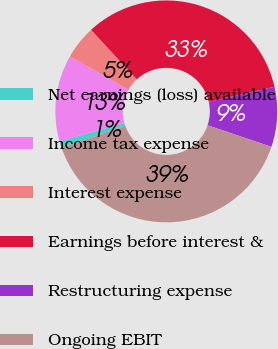Convert chart to OTSL. <chart><loc_0><loc_0><loc_500><loc_500><pie_chart><fcel>Net earnings (loss) available<fcel>Income tax expense<fcel>Interest expense<fcel>Earnings before interest &<fcel>Restructuring expense<fcel>Ongoing EBIT<nl><fcel>1.04%<fcel>12.57%<fcel>4.89%<fcel>33.3%<fcel>8.73%<fcel>39.47%<nl></chart> 